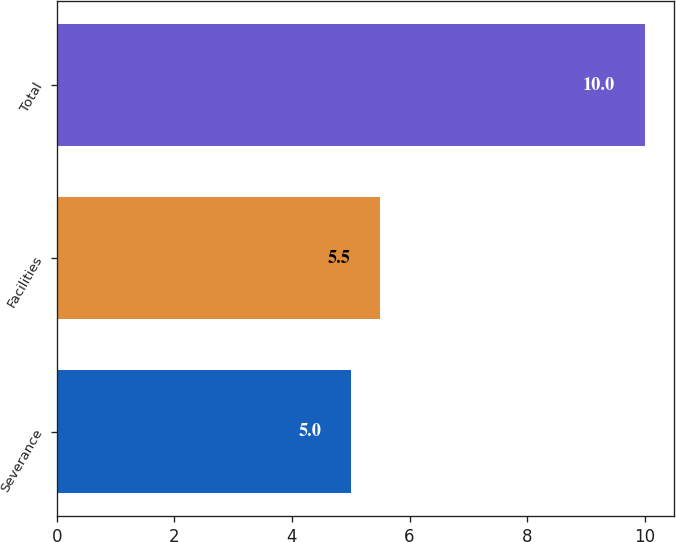<chart> <loc_0><loc_0><loc_500><loc_500><bar_chart><fcel>Severance<fcel>Facilities<fcel>Total<nl><fcel>5<fcel>5.5<fcel>10<nl></chart> 